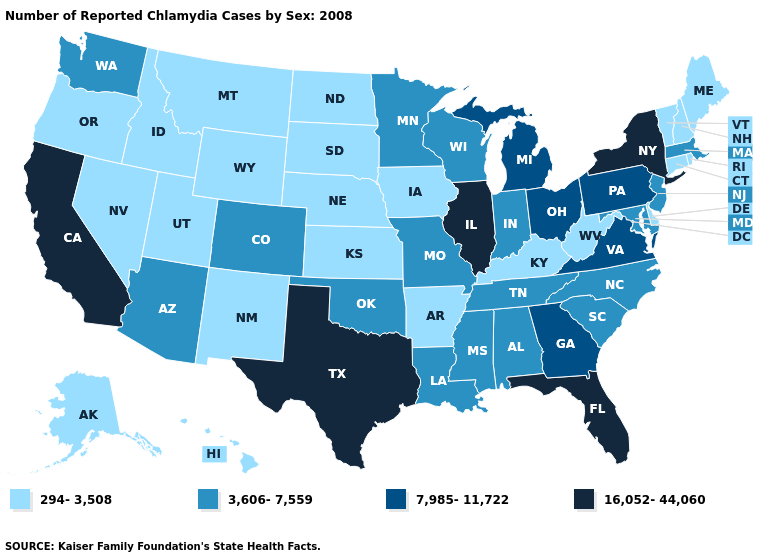Is the legend a continuous bar?
Write a very short answer. No. Which states have the lowest value in the South?
Concise answer only. Arkansas, Delaware, Kentucky, West Virginia. Which states have the highest value in the USA?
Answer briefly. California, Florida, Illinois, New York, Texas. What is the highest value in states that border South Carolina?
Keep it brief. 7,985-11,722. Among the states that border South Dakota , which have the lowest value?
Concise answer only. Iowa, Montana, Nebraska, North Dakota, Wyoming. What is the lowest value in the MidWest?
Keep it brief. 294-3,508. Does Kentucky have a higher value than Alaska?
Give a very brief answer. No. Does North Carolina have a lower value than Louisiana?
Concise answer only. No. Does Montana have the lowest value in the USA?
Quick response, please. Yes. Which states have the highest value in the USA?
Keep it brief. California, Florida, Illinois, New York, Texas. Name the states that have a value in the range 7,985-11,722?
Short answer required. Georgia, Michigan, Ohio, Pennsylvania, Virginia. Name the states that have a value in the range 3,606-7,559?
Give a very brief answer. Alabama, Arizona, Colorado, Indiana, Louisiana, Maryland, Massachusetts, Minnesota, Mississippi, Missouri, New Jersey, North Carolina, Oklahoma, South Carolina, Tennessee, Washington, Wisconsin. Name the states that have a value in the range 3,606-7,559?
Concise answer only. Alabama, Arizona, Colorado, Indiana, Louisiana, Maryland, Massachusetts, Minnesota, Mississippi, Missouri, New Jersey, North Carolina, Oklahoma, South Carolina, Tennessee, Washington, Wisconsin. Which states have the lowest value in the USA?
Short answer required. Alaska, Arkansas, Connecticut, Delaware, Hawaii, Idaho, Iowa, Kansas, Kentucky, Maine, Montana, Nebraska, Nevada, New Hampshire, New Mexico, North Dakota, Oregon, Rhode Island, South Dakota, Utah, Vermont, West Virginia, Wyoming. What is the value of Montana?
Quick response, please. 294-3,508. 